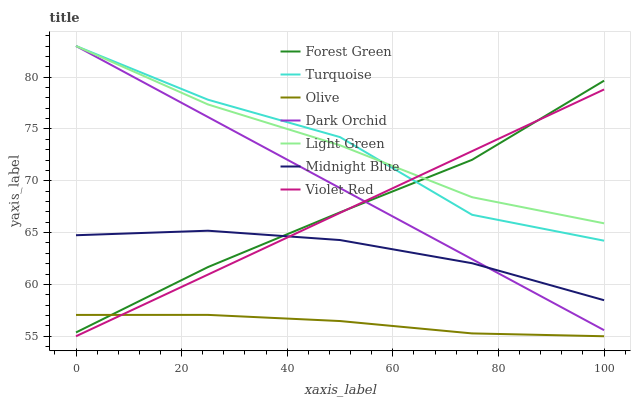Does Midnight Blue have the minimum area under the curve?
Answer yes or no. No. Does Midnight Blue have the maximum area under the curve?
Answer yes or no. No. Is Midnight Blue the smoothest?
Answer yes or no. No. Is Midnight Blue the roughest?
Answer yes or no. No. Does Midnight Blue have the lowest value?
Answer yes or no. No. Does Midnight Blue have the highest value?
Answer yes or no. No. Is Olive less than Light Green?
Answer yes or no. Yes. Is Light Green greater than Midnight Blue?
Answer yes or no. Yes. Does Olive intersect Light Green?
Answer yes or no. No. 